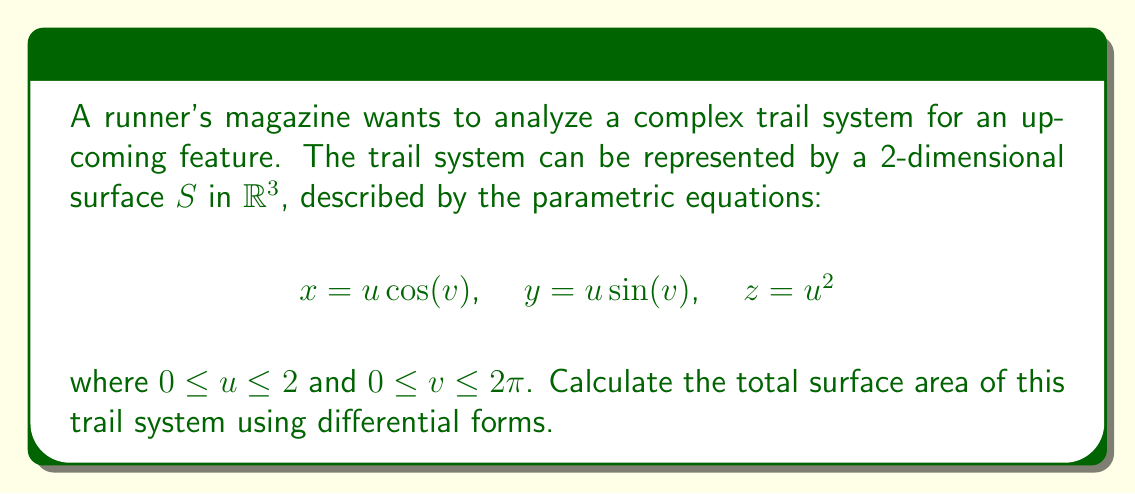What is the answer to this math problem? To calculate the surface area using differential forms, we follow these steps:

1) First, we need to find the tangent vectors to the surface:

   $\mathbf{r}_u = (\cos(v), \sin(v), 2u)$
   $\mathbf{r}_v = (-u\sin(v), u\cos(v), 0)$

2) The surface area element is given by the magnitude of the cross product of these vectors:

   $dS = |\mathbf{r}_u \times \mathbf{r}_v| du dv$

3) Calculate the cross product:

   $\mathbf{r}_u \times \mathbf{r}_v = (2u^2\cos(v), 2u^2\sin(v), u)$

4) Find the magnitude:

   $|\mathbf{r}_u \times \mathbf{r}_v| = \sqrt{4u^4\cos^2(v) + 4u^4\sin^2(v) + u^2}$
                                      $= \sqrt{4u^4 + u^2}$
                                      $= u\sqrt{4u^2 + 1}$

5) Therefore, the surface area element is:

   $dS = u\sqrt{4u^2 + 1} du dv$

6) The total surface area is the double integral of this element:

   $A = \int_0^{2\pi} \int_0^2 u\sqrt{4u^2 + 1} du dv$

7) Evaluate the inner integral:

   $\int_0^2 u\sqrt{4u^2 + 1} du = \frac{1}{12}(4u^2+1)^{3/2}|_0^2$
                                 $= \frac{1}{12}(17^{3/2} - 1)$

8) Multiply by $2\pi$ for the outer integral:

   $A = 2\pi \cdot \frac{1}{12}(17^{3/2} - 1) = \frac{\pi}{6}(17^{3/2} - 1)$
Answer: $\frac{\pi}{6}(17^{3/2} - 1)$ square units 